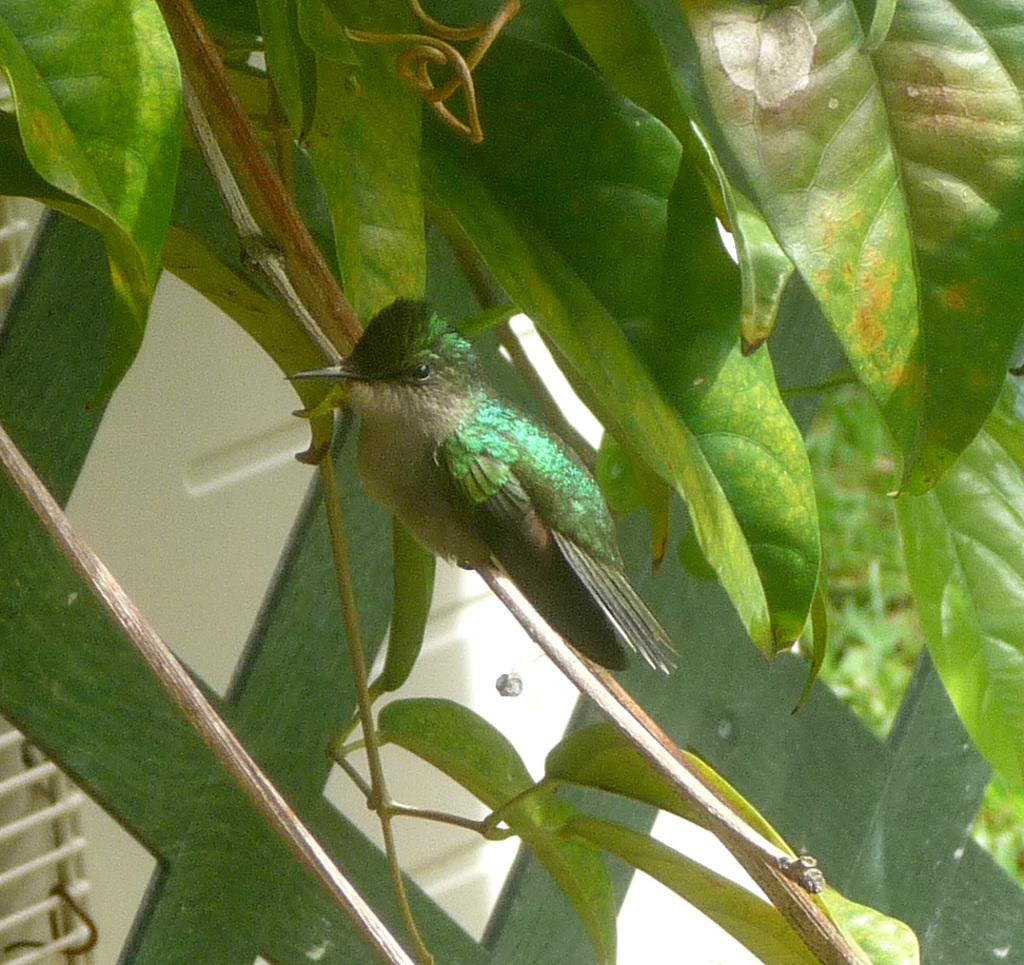What type of animal can be seen in the image? There is a bird in the image. What color is the bird? The bird is green in color. Where is the bird located in the image? The bird is on the branch of a tree. What else can be seen in the image besides the bird? There are leaves in the image. What is visible in the background of the image? There is a house in the background of the image. Can you tell me how many times the bird jumps in the image? There is no indication that the bird is jumping in the image; it is perched on a branch. What type of jewelry is the bird wearing in the image? There is no jewelry, such as a locket, present on the bird in the image. 